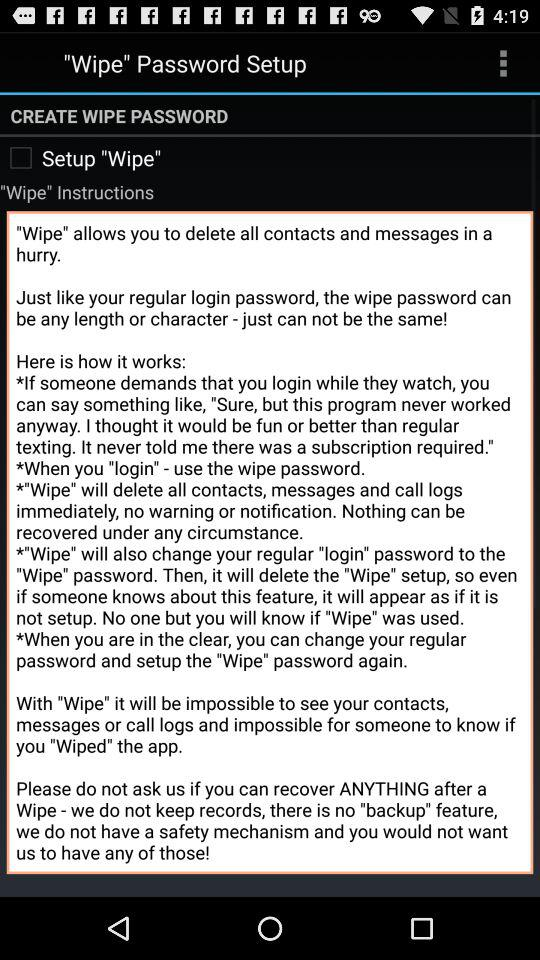What is the status of the "Setup "Wipe""? The status of the "Setup "Wipe"" is "off". 